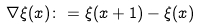<formula> <loc_0><loc_0><loc_500><loc_500>\nabla \xi ( x ) \colon = \xi ( x + 1 ) - \xi ( x )</formula> 